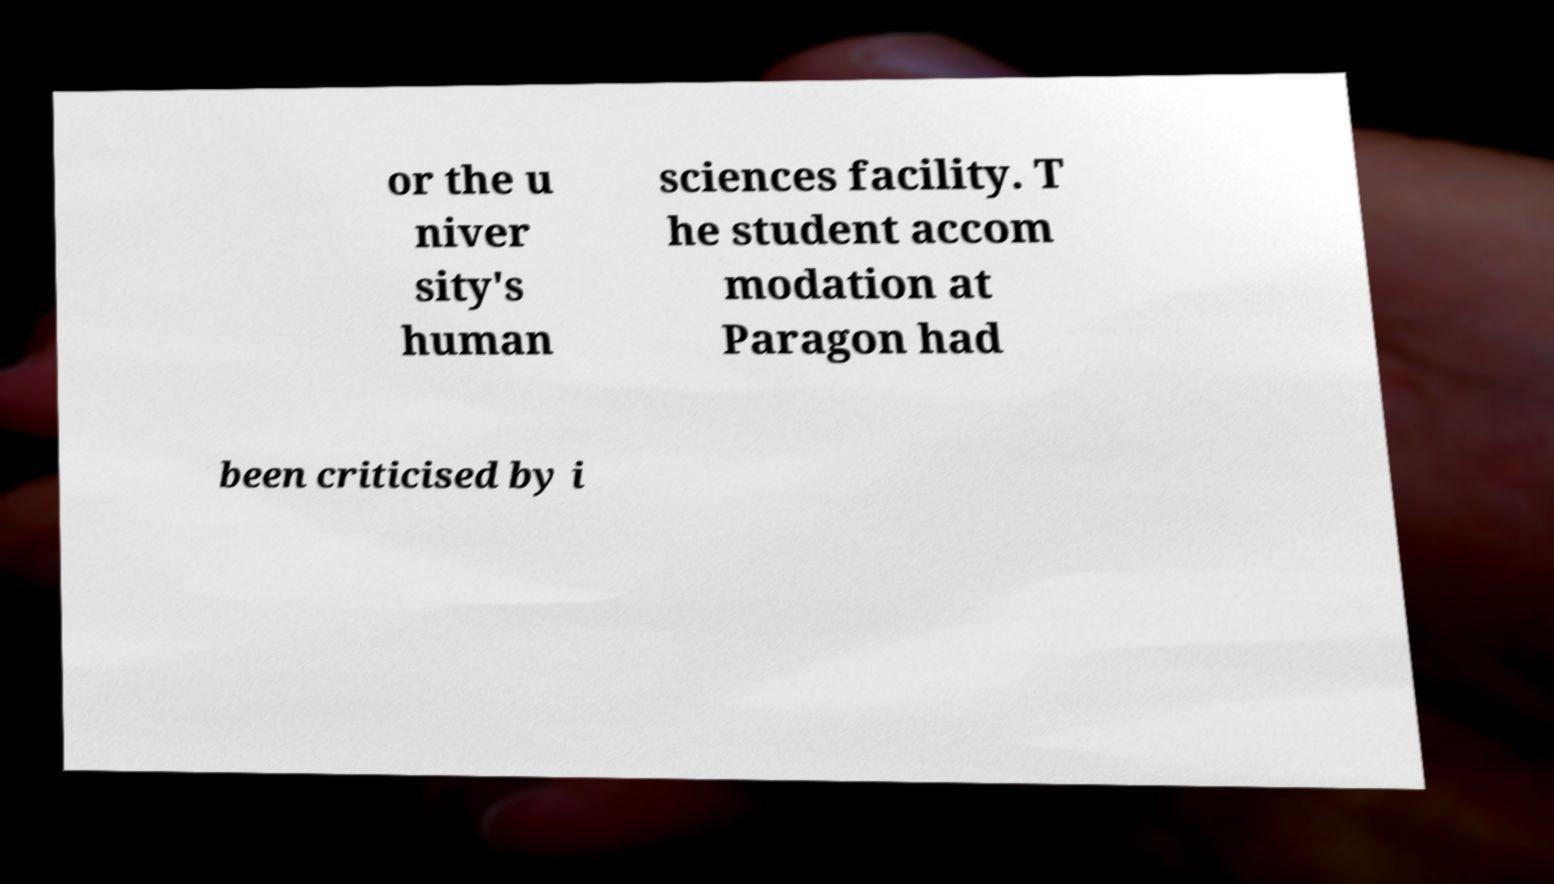I need the written content from this picture converted into text. Can you do that? or the u niver sity's human sciences facility. T he student accom modation at Paragon had been criticised by i 